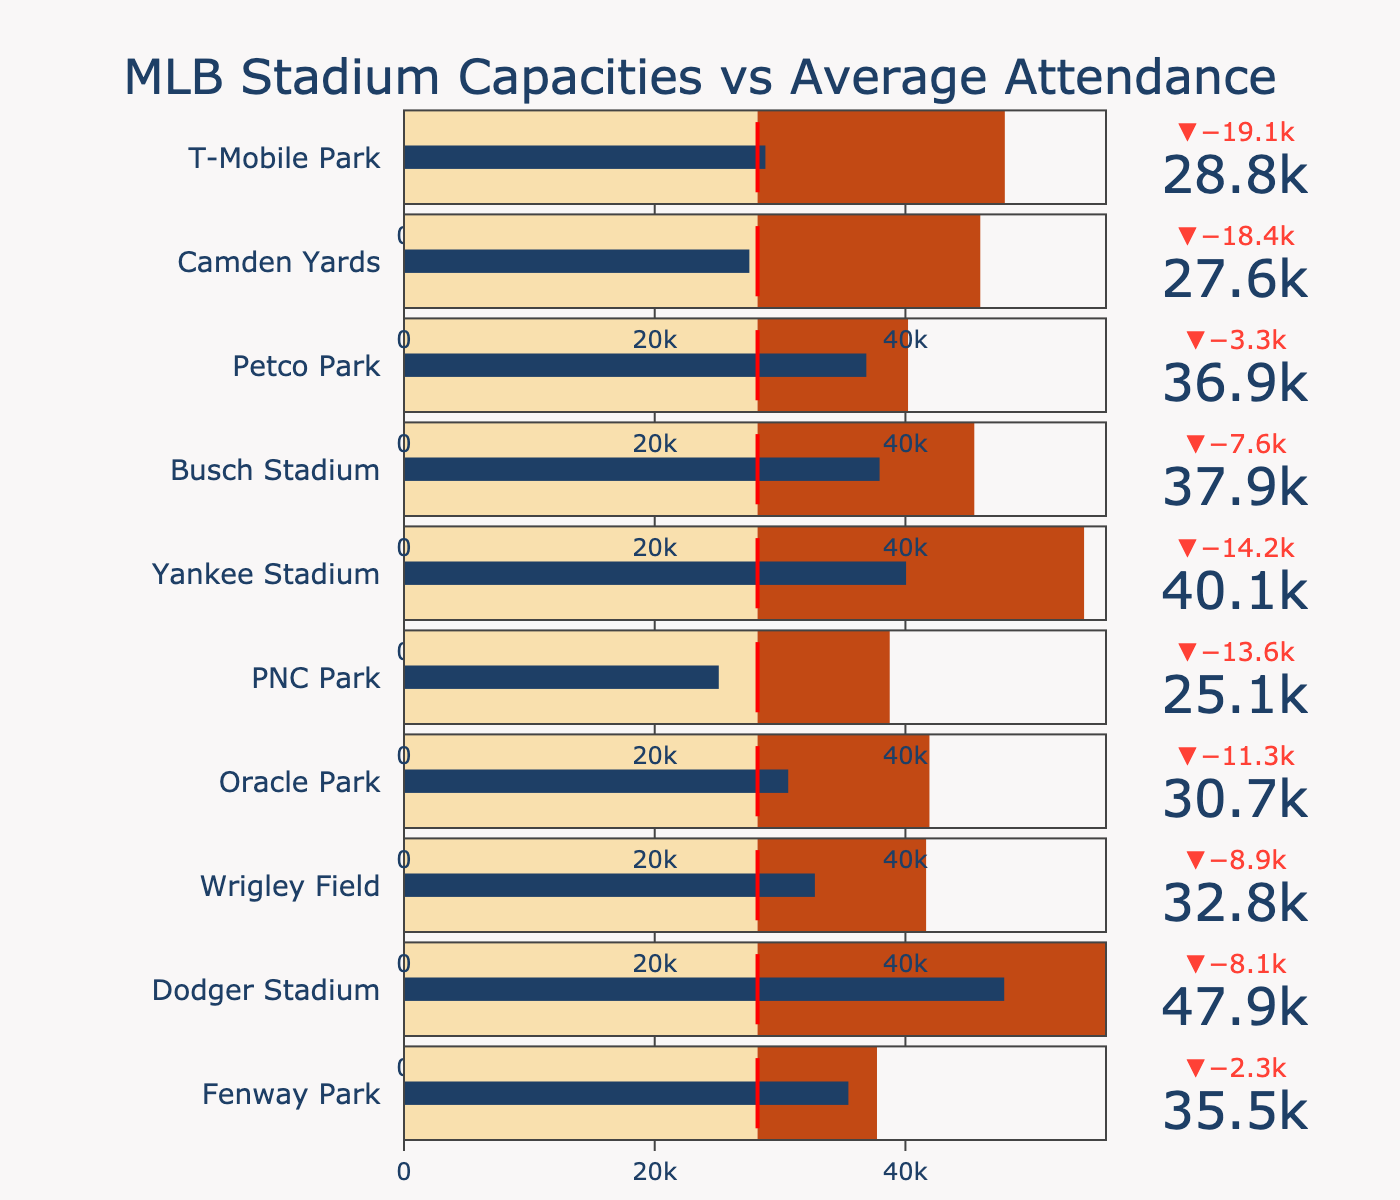What is the average attendance at Dodger Stadium? The value shown for Dodger Stadium's average attendance on the bullet chart is 47880.
Answer: 47880 How many stadiums have an average attendance higher than the league average? There are six stadiums: Fenway Park, Dodger Stadium, Yankee Stadium, Busch Stadium, Petco Park, and T-Mobile Park, whose average attendance surpasses the league average threshold.
Answer: 6 Which stadium has the highest capacity? By comparing the maximum end of the capacity ranges on each bullet chart, Dodger Stadium has the highest capacity at 56000.
Answer: Dodger Stadium How much higher is Fenway Park's average attendance than PNC Park's average attendance? Fenway Park's average attendance is 35450, and PNC Park's is 25110. The difference between them is 35450 - 25110 = 10340.
Answer: 10340 Which stadium has the smallest delta between its average attendance and capacity? Delta is represented by the difference between the end of the blue bar (average attendance) and the maximum range of the axis (capacity). The smallest delta is seen at T-Mobile Park.
Answer: T-Mobile Park What is the average capacity of all the stadiums? Sum the capacities of all stadiums (37731 + 56000 + 41649 + 41915 + 38747 + 54251 + 45494 + 40209 + 45971 + 47929) = 451896, then divide by the number of stadiums (10). 451896 / 10 = 45189.6
Answer: 45189.6 Compare the average attendance at Yankee Stadium and Busch Stadium. Which one is higher? Yankee Stadium's average attendance is shown as 40050, while Busch Stadium's is 37940. Yankee Stadium's attendance is higher by 40050 - 37940 = 2110.
Answer: Yankee Stadium Which stadium has the lowest average attendance, and what is that value? The lowest average attendance value is found in PNC Park, which is 25110.
Answer: PNC Park What is the range of capacities among the listed stadiums? The minimum capacity is Fenway Park with 37731, and the maximum is Dodger Stadium with 56000. The range is 56000 - 37731 = 18269.
Answer: 18269 